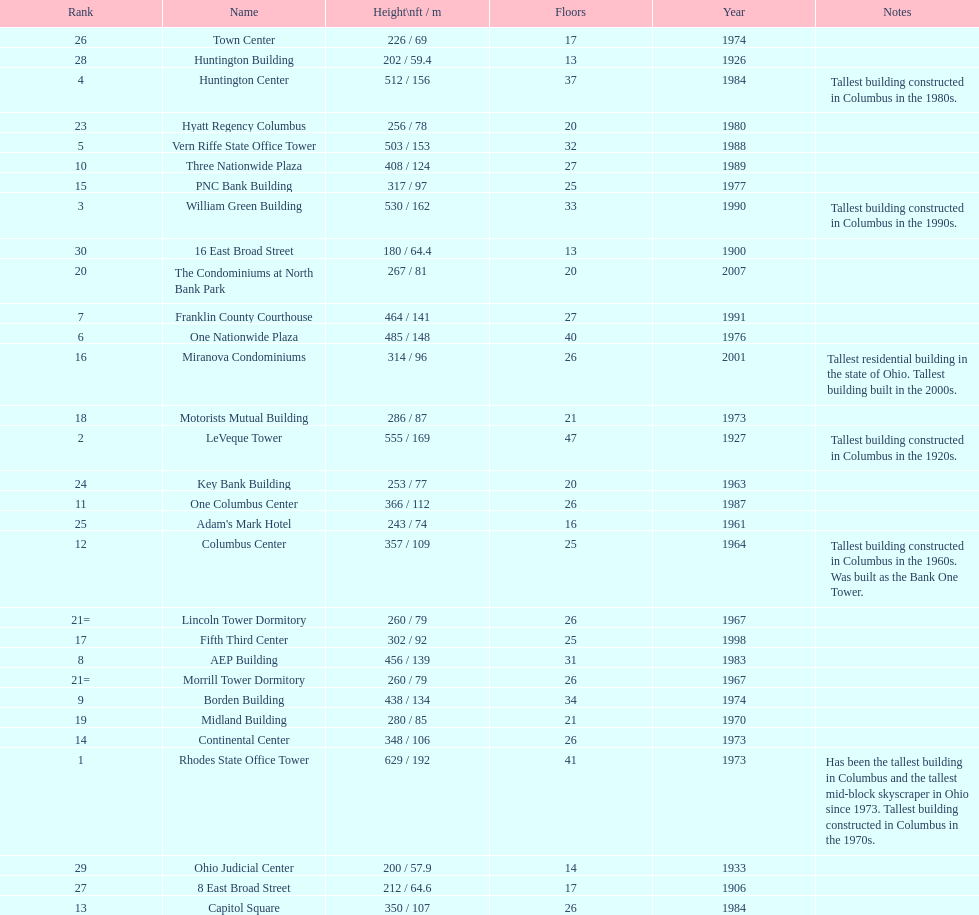Which is taller, the aep building or the one columbus center? AEP Building. 